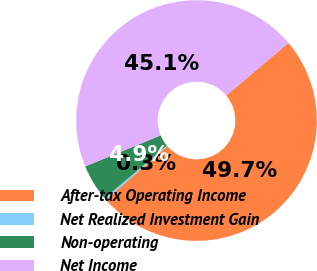Convert chart to OTSL. <chart><loc_0><loc_0><loc_500><loc_500><pie_chart><fcel>After-tax Operating Income<fcel>Net Realized Investment Gain<fcel>Non-operating<fcel>Net Income<nl><fcel>49.72%<fcel>0.28%<fcel>4.94%<fcel>45.06%<nl></chart> 